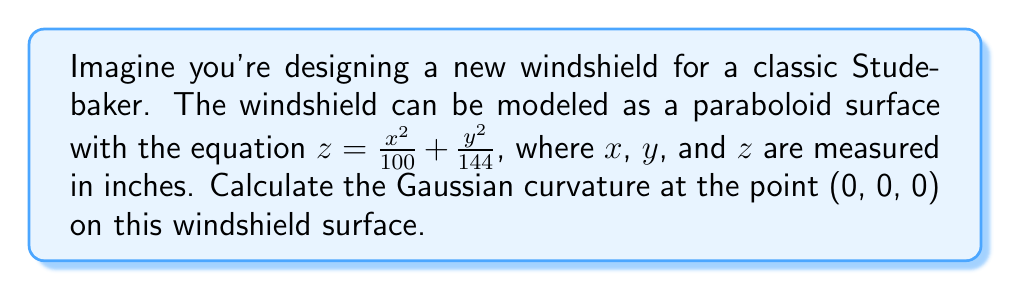Can you solve this math problem? To find the Gaussian curvature of the windshield surface, we'll follow these steps:

1) The surface is given by $z = f(x,y) = \frac{x^2}{100} + \frac{y^2}{144}$

2) We need to calculate the first and second partial derivatives:

   $f_x = \frac{\partial f}{\partial x} = \frac{2x}{100}$
   $f_y = \frac{\partial f}{\partial y} = \frac{2y}{144}$
   $f_{xx} = \frac{\partial^2 f}{\partial x^2} = \frac{2}{100}$
   $f_{yy} = \frac{\partial^2 f}{\partial y^2} = \frac{2}{144}$
   $f_{xy} = f_{yx} = \frac{\partial^2 f}{\partial x \partial y} = 0$

3) The Gaussian curvature K is given by:

   $$K = \frac{f_{xx}f_{yy} - f_{xy}^2}{(1 + f_x^2 + f_y^2)^2}$$

4) At the point (0, 0, 0):
   
   $f_x = f_y = 0$
   $f_{xx} = \frac{2}{100}$
   $f_{yy} = \frac{2}{144}$
   $f_{xy} = 0$

5) Substituting these values into the formula:

   $$K = \frac{(\frac{2}{100})(\frac{2}{144}) - 0^2}{(1 + 0^2 + 0^2)^2} = \frac{\frac{4}{14400}}{1} = \frac{1}{3600}$$

Therefore, the Gaussian curvature at the point (0, 0, 0) is $\frac{1}{3600}$ in$^{-2}$.
Answer: $\frac{1}{3600}$ in$^{-2}$ 